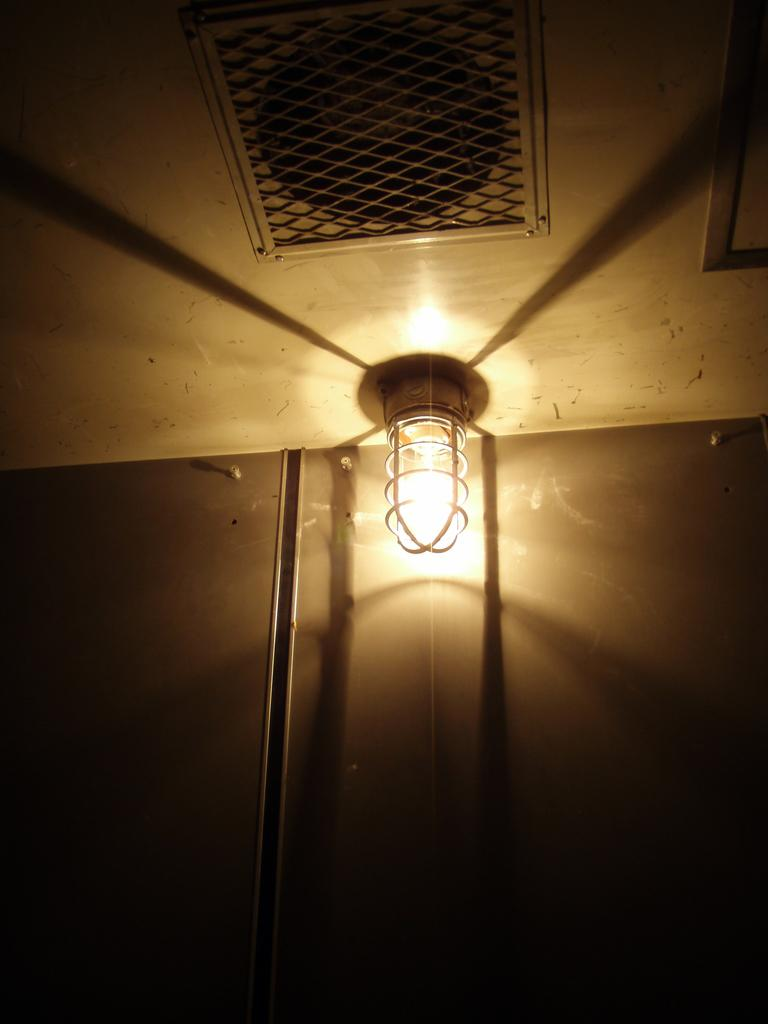What is the source of light in the image? There is a light in the image. What type of structure can be seen in the image? There is a wall in the image. What is located at the top of the image? There is a mesh at the top of the image. What type of animals can be seen at the zoo in the image? There is no zoo present in the image; it only features a light, a wall, and a mesh. What event is taking place in the image? There is no event depicted in the image; it simply shows a light, a wall, and a mesh. 